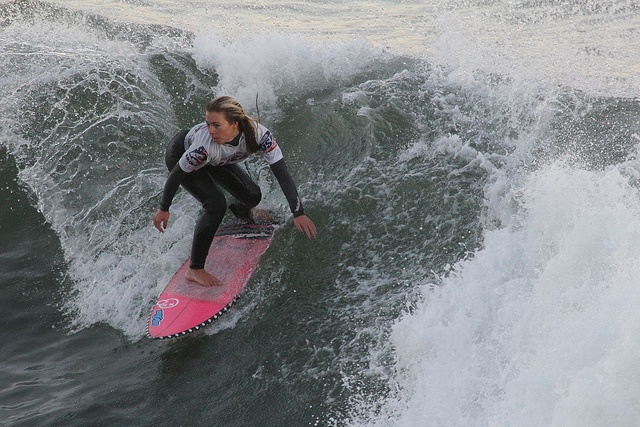Describe the objects in this image and their specific colors. I can see people in lightgray, black, gray, darkgray, and brown tones and surfboard in lightgray, brown, gray, and black tones in this image. 